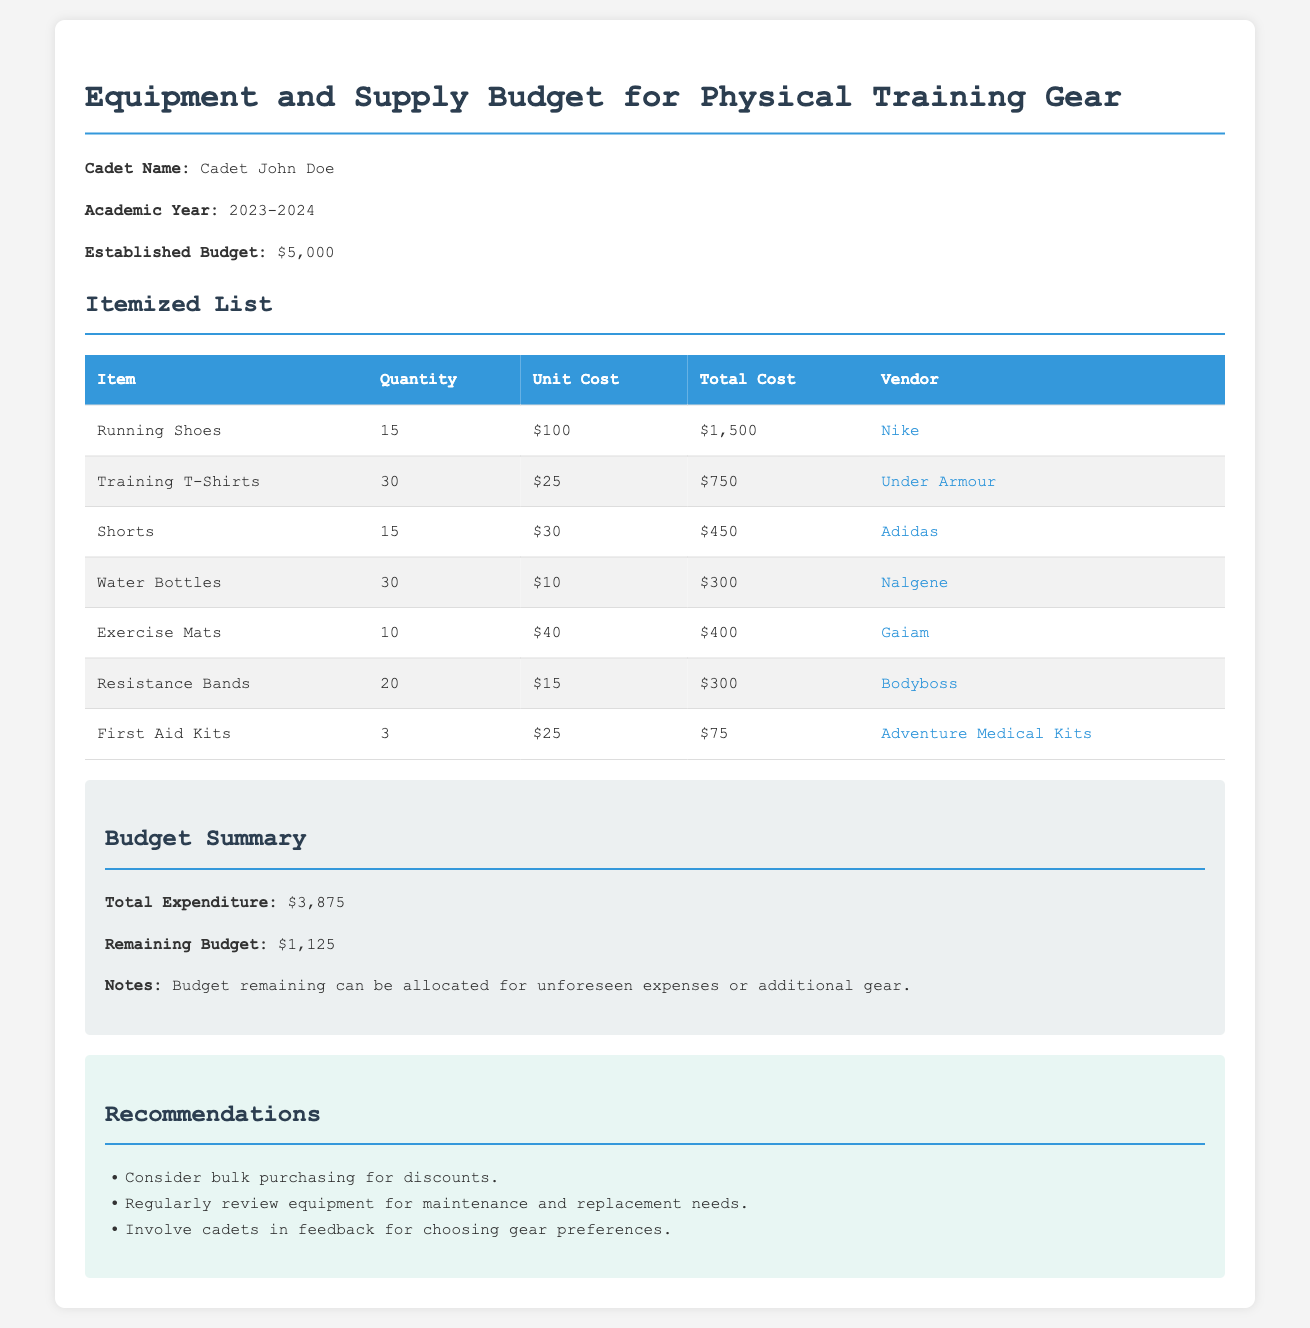What is the established budget? The established budget is explicitly mentioned in the document as $5,000.
Answer: $5,000 How many running shoes are being purchased? The document states that 15 running shoes are included in the budget.
Answer: 15 What is the total cost for training t-shirts? The total cost can be calculated from the quantity and unit cost given, which is 30 t-shirts at $25 each totaling $750.
Answer: $750 Which vendor supplies water bottles? The vendor associated with water bottles is directly listed in the document, which is Nalgene.
Answer: Nalgene What is the remaining budget? The document clearly indicates the remaining budget after expenditures as $1,125.
Answer: $1,125 How many first aid kits are included in the budget? The number of first aid kits mentioned in the document is 3.
Answer: 3 What is the total expenditure for all items? The document provides the total expenditure as $3,875, which is the sum of the costs of all the items listed.
Answer: $3,875 Which item has the highest total cost? By reviewing the total costs, running shoes amounting to $1,500 is identified as the highest cost item.
Answer: Running Shoes What is one of the recommendations given in the document? The document contains multiple recommendations, one of which is to consider bulk purchasing for discounts.
Answer: Consider bulk purchasing for discounts 